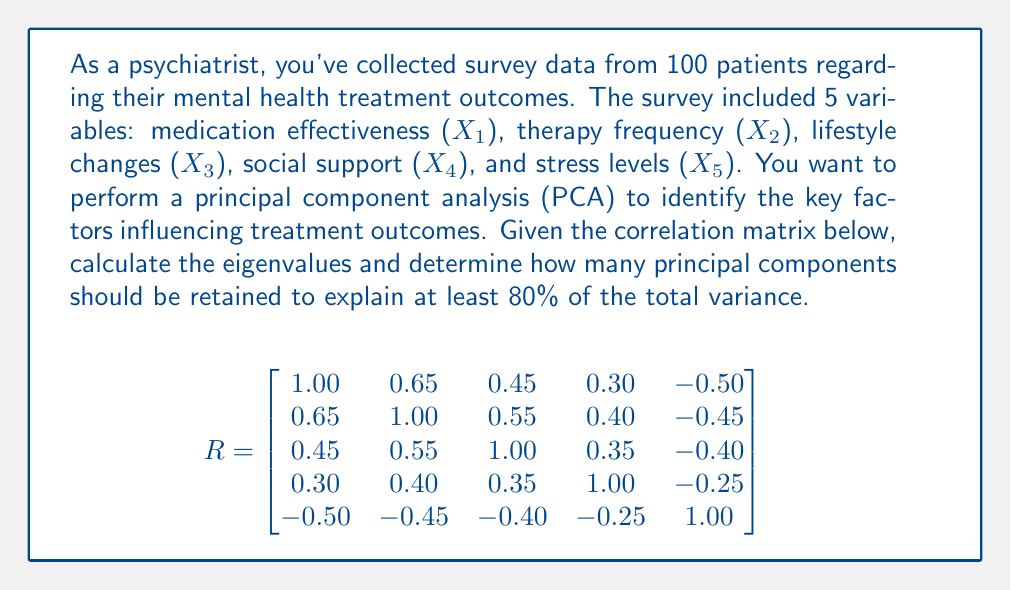Can you answer this question? To solve this problem, we'll follow these steps:

1) Calculate the eigenvalues of the correlation matrix.
2) Compute the proportion of variance explained by each eigenvalue.
3) Determine the cumulative proportion of variance explained.
4) Identify how many principal components are needed to explain at least 80% of the total variance.

Step 1: Calculate eigenvalues
Using a statistical software or matrix calculator, we find the eigenvalues of R:

$$\lambda_1 = 2.6532, \lambda_2 = 1.1845, \lambda_3 = 0.5723, \lambda_4 = 0.3450, \lambda_5 = 0.2450$$

Step 2: Compute proportion of variance explained
The proportion of variance explained by each eigenvalue is calculated as:

$$\text{Proportion}_i = \frac{\lambda_i}{\sum_{j=1}^5 \lambda_j}$$

$$\text{Proportion}_1 = \frac{2.6532}{5} = 0.5306 \text{ or } 53.06\%$$
$$\text{Proportion}_2 = \frac{1.1845}{5} = 0.2369 \text{ or } 23.69\%$$
$$\text{Proportion}_3 = \frac{0.5723}{5} = 0.1145 \text{ or } 11.45\%$$
$$\text{Proportion}_4 = \frac{0.3450}{5} = 0.0690 \text{ or } 6.90\%$$
$$\text{Proportion}_5 = \frac{0.2450}{5} = 0.0490 \text{ or } 4.90\%$$

Step 3: Determine cumulative proportion
Cumulative proportion for the first k components:

$$\text{Cumulative}_k = \sum_{i=1}^k \text{Proportion}_i$$

$$\text{Cumulative}_1 = 53.06\%$$
$$\text{Cumulative}_2 = 53.06\% + 23.69\% = 76.75\%$$
$$\text{Cumulative}_3 = 76.75\% + 11.45\% = 88.20\%$$

Step 4: Identify number of components needed
To explain at least 80% of the total variance, we need to retain the first 3 principal components, as they cumulatively explain 88.20% of the total variance, which exceeds the 80% threshold.
Answer: 3 principal components 